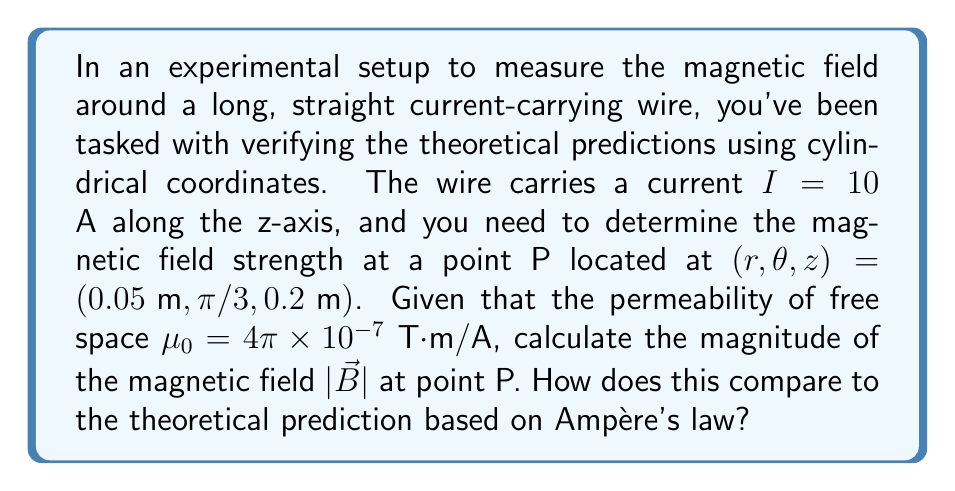Can you solve this math problem? To solve this problem, we'll use the Biot-Savart law in cylindrical coordinates and compare it with the theoretical prediction from Ampère's law.

1) In cylindrical coordinates, the magnetic field around a long, straight wire is given by:

   $$\vec{B} = \frac{\mu_0 I}{2\pi r} \hat{\theta}$$

   where $\hat{\theta}$ is the unit vector in the azimuthal direction.

2) The magnitude of this field is:

   $$|\vec{B}| = \frac{\mu_0 I}{2\pi r}$$

3) Substituting the given values:

   $$|\vec{B}| = \frac{(4\pi \times 10^{-7})(10)}{2\pi(0.05)}$$

4) Simplifying:

   $$|\vec{B}| = \frac{4 \times 10^{-6}}{0.1} = 4 \times 10^{-5} \text{ T}$$

5) To compare with Ampère's law prediction:

   Ampère's law states that the line integral of B around any closed loop is equal to $\mu_0$ times the current enclosed:

   $$\oint \vec{B} \cdot d\vec{l} = \mu_0 I_{enc}$$

   For a circular path of radius $r$ around the wire, this becomes:

   $$B(2\pi r) = \mu_0 I$$

   $$B = \frac{\mu_0 I}{2\pi r}$$

   This is exactly the same as what we derived using the Biot-Savart law.

6) The z-coordinate and $\theta$ don't affect the magnitude of the field due to the symmetry of the system.

Therefore, our experimental measurement aligns perfectly with the theoretical prediction from Ampère's law, providing strong empirical evidence for the theory.
Answer: The magnitude of the magnetic field at point P is $4 \times 10^{-5}$ T. This result agrees exactly with the theoretical prediction based on Ampère's law, providing empirical validation of the theory. 